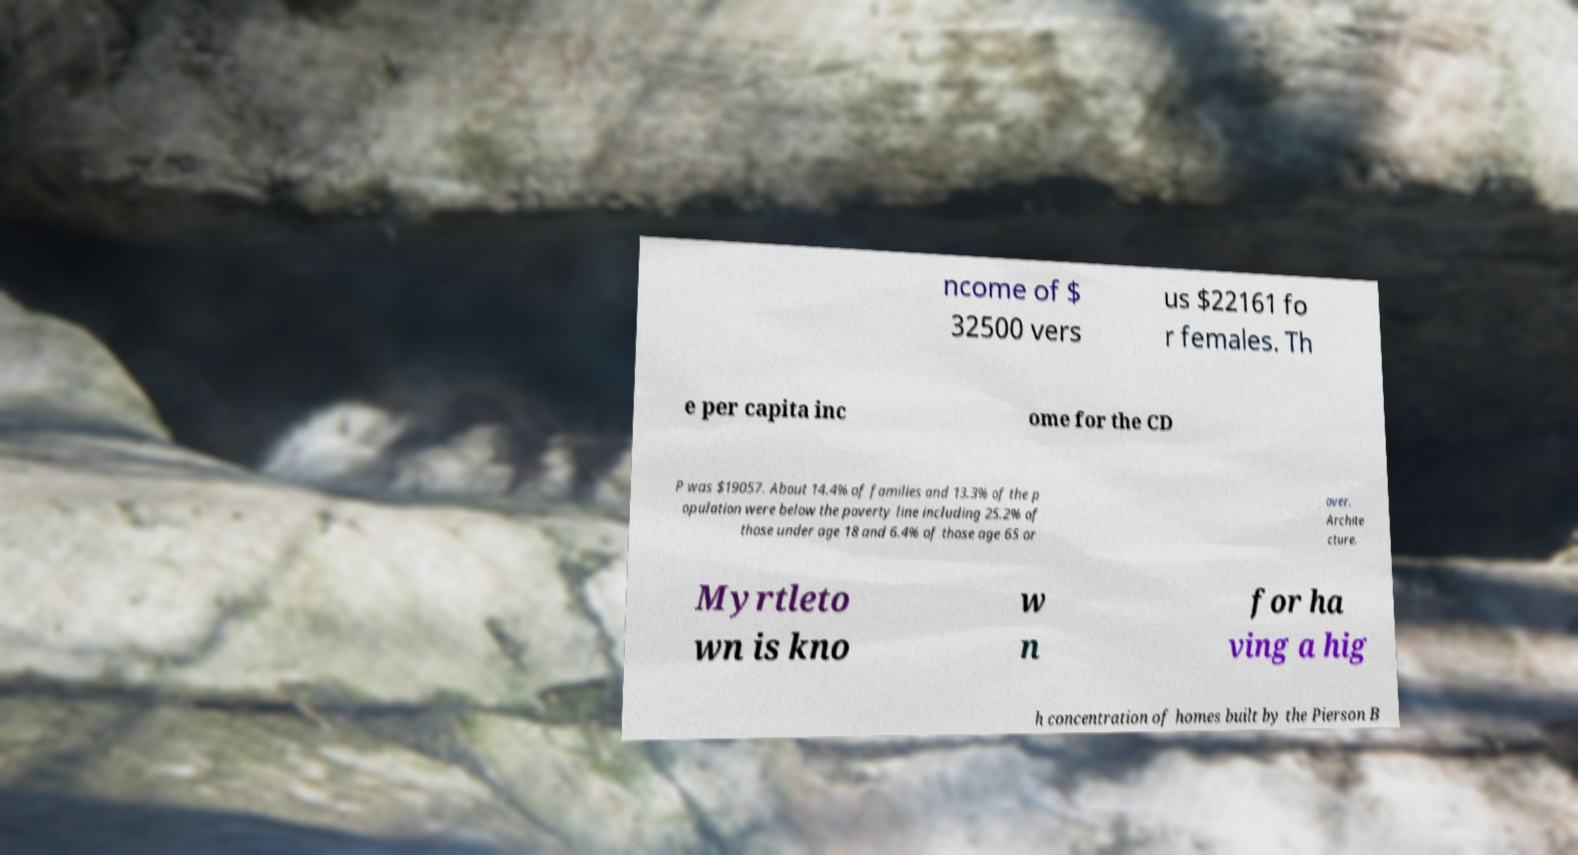There's text embedded in this image that I need extracted. Can you transcribe it verbatim? ncome of $ 32500 vers us $22161 fo r females. Th e per capita inc ome for the CD P was $19057. About 14.4% of families and 13.3% of the p opulation were below the poverty line including 25.2% of those under age 18 and 6.4% of those age 65 or over. Archite cture. Myrtleto wn is kno w n for ha ving a hig h concentration of homes built by the Pierson B 